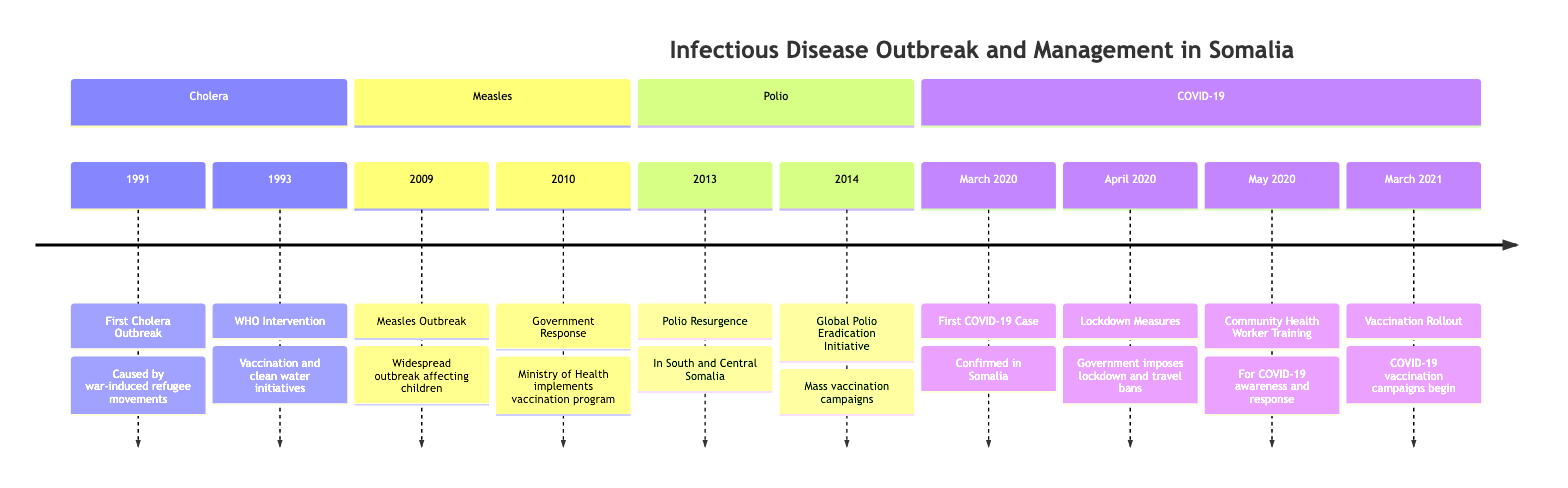What year did the first cholera outbreak occur in Somalia? The diagram indicates that the first cholera outbreak happened in 1991. This is stated directly in the timeline under the cholera section.
Answer: 1991 What key intervention was initiated by the WHO in response to the cholera outbreak? According to the diagram, the WHO intervention in 1993 involved vaccination and clean water initiatives. This is clearly highlighted in the timeline.
Answer: Vaccination and clean water initiatives How many measles outbreaks are noted in the timeline? The diagram shows one measles outbreak in 2009, as indicated explicitly in the measles section of the timeline.
Answer: One What action did the Ministry of Health take in 2010 regarding the measles outbreak? The diagram states that in 2010, the Ministry of Health implemented a vaccination program in response to the measles outbreak, which is directly indicated in that section of the timeline.
Answer: Vaccination program What significant event related to polio occurred in South and Central Somalia in 2013? The timeline specifies that there was a polio resurgence in South and Central Somalia in 2013, reflecting a major event in the polio section.
Answer: Polio Resurgence What measure did the government impose in April 2020 in response to COVID-19? The diagram states that in April 2020, the government imposed lockdown measures and travel bans as a response to the COVID-19 pandemic, indicated in the timeline under the COVID-19 section.
Answer: Lockdown and travel bans What was initiated in May 2020 to support COVID-19 response efforts? The diagram highlights that in May 2020, humanitarian efforts included the training of community health workers for COVID-19 awareness and response, a key intervention noted in the timeline.
Answer: Community Health Worker Training How many years passed between the first confirmed COVID-19 case and the start of vaccination rollout? The first COVID-19 case was confirmed in March 2020, and the vaccination rollout began in March 2021. Therefore, one year passed between these two events, as calculated by assessing the timeline details.
Answer: One year What overarching theme is seen in the timeline regarding health responses in Somalia? The diagram suggests an overarching theme of public health interventions with key vaccinations, training, and response strategies noted throughout various outbreaks. This reflects a structured response to health crises.
Answer: Public health interventions 